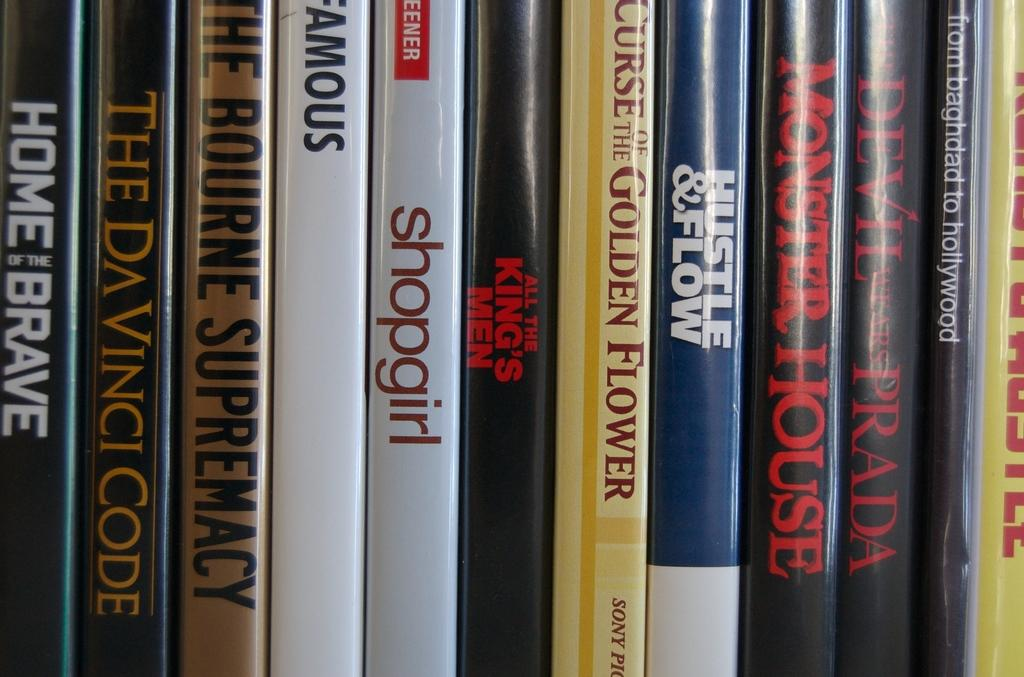<image>
Create a compact narrative representing the image presented. The book to the right of shopgirl is All The King's Men. 